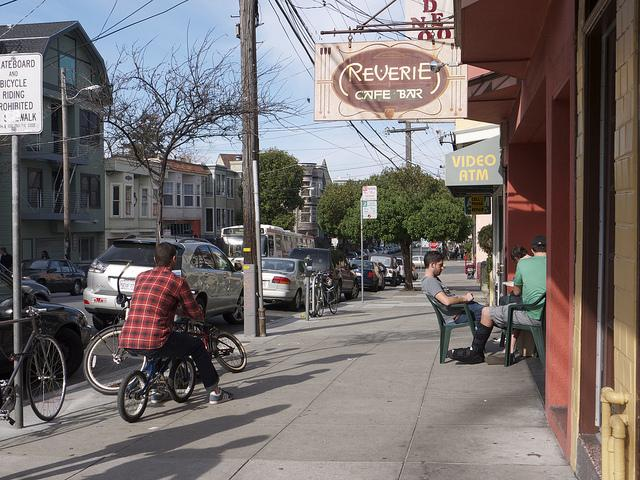What can the men do here?

Choices:
A) ride
B) haircut
C) compete
D) drink drink 